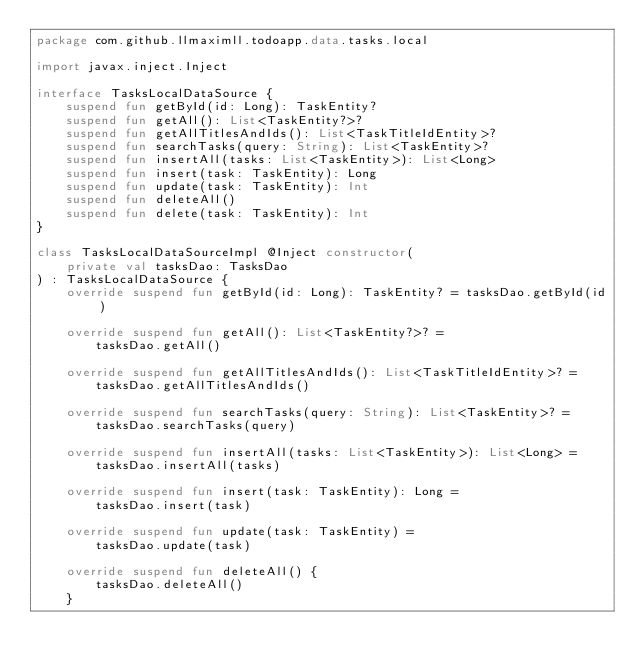<code> <loc_0><loc_0><loc_500><loc_500><_Kotlin_>package com.github.llmaximll.todoapp.data.tasks.local

import javax.inject.Inject

interface TasksLocalDataSource {
    suspend fun getById(id: Long): TaskEntity?
    suspend fun getAll(): List<TaskEntity?>?
    suspend fun getAllTitlesAndIds(): List<TaskTitleIdEntity>?
    suspend fun searchTasks(query: String): List<TaskEntity>?
    suspend fun insertAll(tasks: List<TaskEntity>): List<Long>
    suspend fun insert(task: TaskEntity): Long
    suspend fun update(task: TaskEntity): Int
    suspend fun deleteAll()
    suspend fun delete(task: TaskEntity): Int
}

class TasksLocalDataSourceImpl @Inject constructor(
    private val tasksDao: TasksDao
) : TasksLocalDataSource {
    override suspend fun getById(id: Long): TaskEntity? = tasksDao.getById(id)

    override suspend fun getAll(): List<TaskEntity?>? =
        tasksDao.getAll()

    override suspend fun getAllTitlesAndIds(): List<TaskTitleIdEntity>? =
        tasksDao.getAllTitlesAndIds()

    override suspend fun searchTasks(query: String): List<TaskEntity>? =
        tasksDao.searchTasks(query)

    override suspend fun insertAll(tasks: List<TaskEntity>): List<Long> =
        tasksDao.insertAll(tasks)

    override suspend fun insert(task: TaskEntity): Long =
        tasksDao.insert(task)

    override suspend fun update(task: TaskEntity) =
        tasksDao.update(task)

    override suspend fun deleteAll() {
        tasksDao.deleteAll()
    }
</code> 